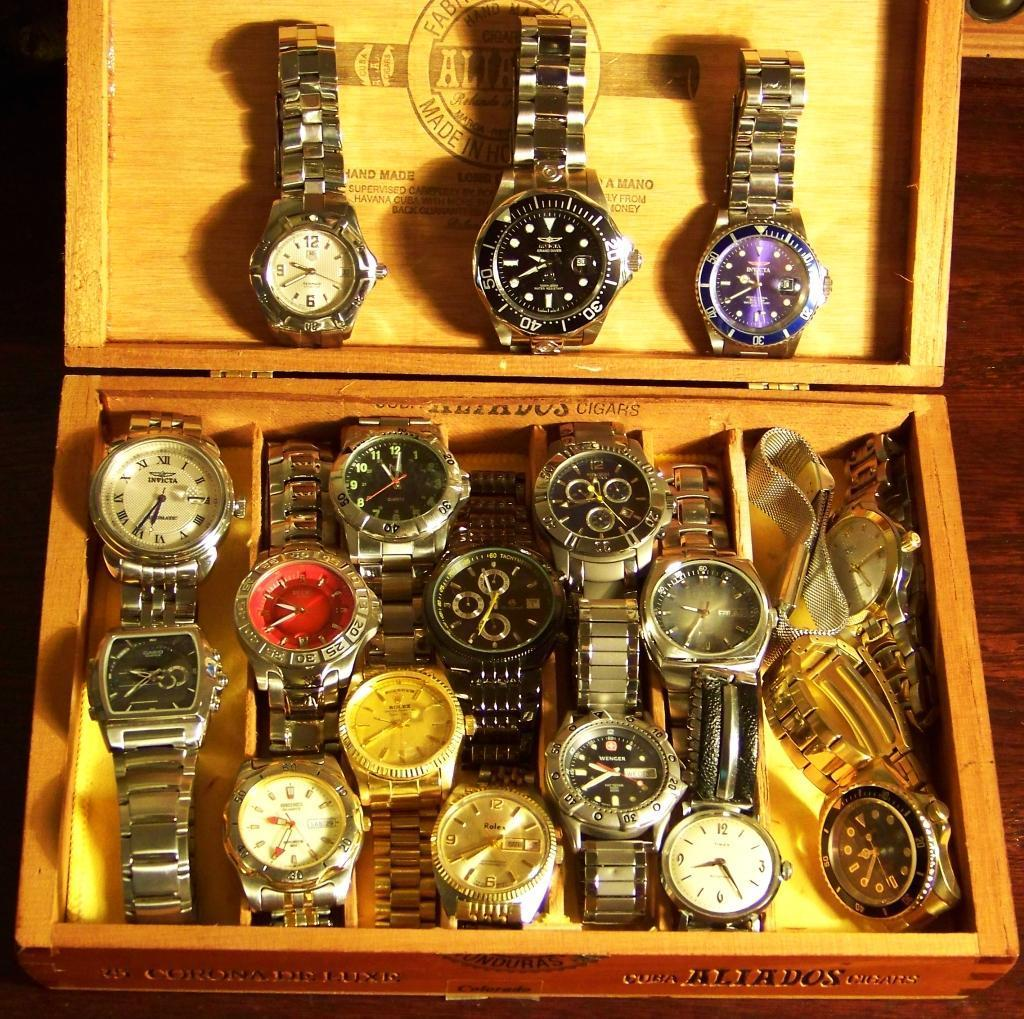What is the main object in the image? There is a box in the image. What is inside the box? There are watches inside the box. What type of decision can be seen being made by the badge in the image? There is no badge present in the image, so no decision can be made by a badge. 